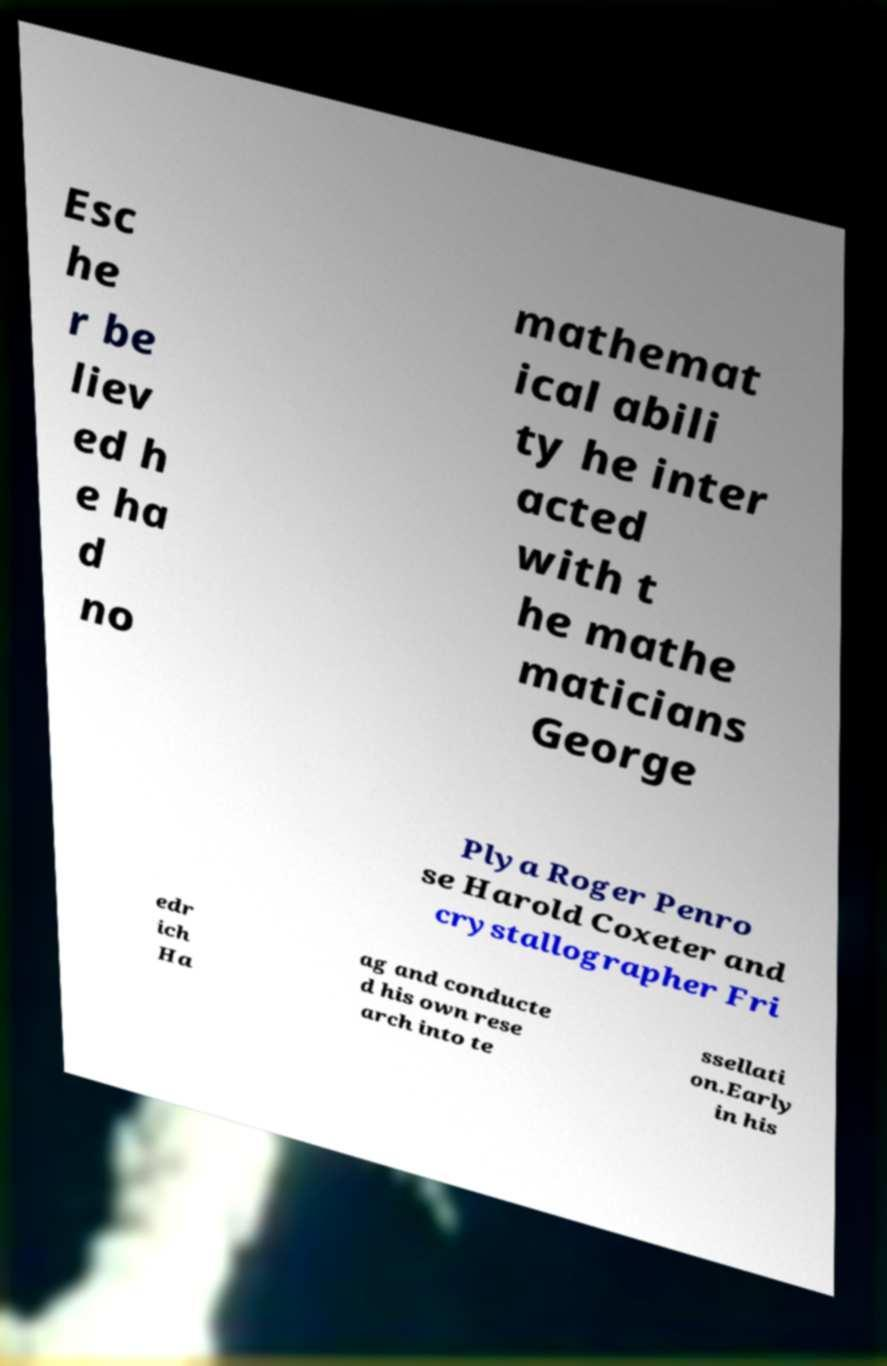Please identify and transcribe the text found in this image. Esc he r be liev ed h e ha d no mathemat ical abili ty he inter acted with t he mathe maticians George Plya Roger Penro se Harold Coxeter and crystallographer Fri edr ich Ha ag and conducte d his own rese arch into te ssellati on.Early in his 